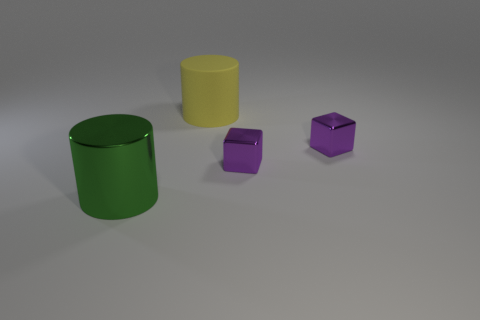There is a matte thing that is the same size as the green cylinder; what is its color?
Give a very brief answer. Yellow. There is a cylinder behind the green metallic thing; is it the same size as the thing that is to the left of the yellow cylinder?
Make the answer very short. Yes. How big is the cylinder behind the large cylinder to the left of the cylinder right of the big shiny cylinder?
Offer a very short reply. Large. There is a big thing that is in front of the big cylinder on the right side of the big green thing; what shape is it?
Keep it short and to the point. Cylinder. There is a large cylinder left of the large matte object; is it the same color as the big rubber object?
Keep it short and to the point. No. Is there a large cylinder that has the same material as the green object?
Provide a short and direct response. No. The green metal cylinder has what size?
Offer a terse response. Large. What size is the shiny thing that is left of the cylinder to the right of the green thing?
Ensure brevity in your answer.  Large. There is another object that is the same shape as the big green metal object; what is it made of?
Your response must be concise. Rubber. How many cylinders are there?
Offer a terse response. 2. 